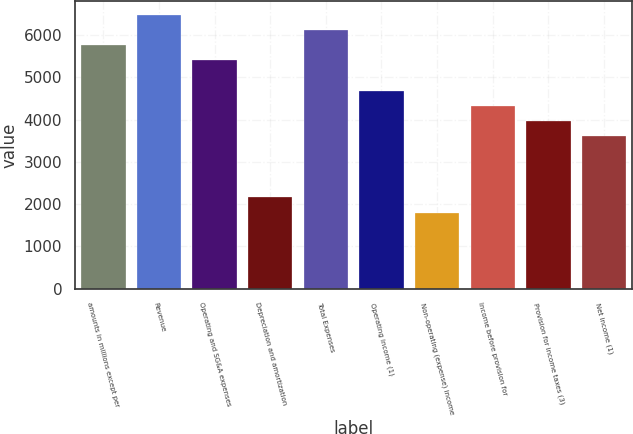Convert chart. <chart><loc_0><loc_0><loc_500><loc_500><bar_chart><fcel>amounts in millions except per<fcel>Revenue<fcel>Operating and SG&A expenses<fcel>Depreciation and amortization<fcel>Total Expenses<fcel>Operating income (1)<fcel>Non-operating (expense) income<fcel>Income before provision for<fcel>Provision for income taxes (3)<fcel>Net income (1)<nl><fcel>5765.84<fcel>6486.4<fcel>5405.56<fcel>2163.04<fcel>6126.12<fcel>4685<fcel>1802.76<fcel>4324.72<fcel>3964.44<fcel>3604.16<nl></chart> 